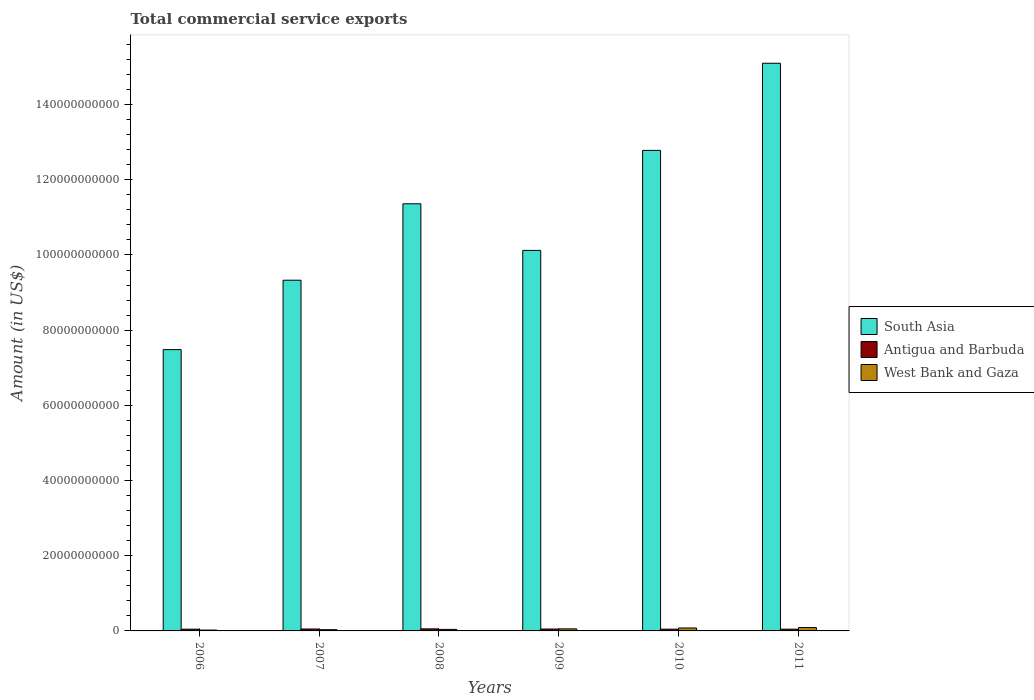How many groups of bars are there?
Your answer should be compact. 6. Are the number of bars per tick equal to the number of legend labels?
Offer a very short reply. Yes. Are the number of bars on each tick of the X-axis equal?
Your answer should be very brief. Yes. How many bars are there on the 6th tick from the left?
Your answer should be compact. 3. What is the label of the 6th group of bars from the left?
Offer a terse response. 2011. What is the total commercial service exports in West Bank and Gaza in 2009?
Make the answer very short. 5.57e+08. Across all years, what is the maximum total commercial service exports in Antigua and Barbuda?
Provide a succinct answer. 5.47e+08. Across all years, what is the minimum total commercial service exports in South Asia?
Give a very brief answer. 7.48e+1. In which year was the total commercial service exports in Antigua and Barbuda minimum?
Keep it short and to the point. 2006. What is the total total commercial service exports in West Bank and Gaza in the graph?
Offer a very short reply. 3.21e+09. What is the difference between the total commercial service exports in Antigua and Barbuda in 2006 and that in 2010?
Keep it short and to the point. -3.92e+06. What is the difference between the total commercial service exports in South Asia in 2008 and the total commercial service exports in Antigua and Barbuda in 2007?
Provide a short and direct response. 1.13e+11. What is the average total commercial service exports in West Bank and Gaza per year?
Keep it short and to the point. 5.34e+08. In the year 2010, what is the difference between the total commercial service exports in West Bank and Gaza and total commercial service exports in Antigua and Barbuda?
Your answer should be compact. 3.17e+08. In how many years, is the total commercial service exports in Antigua and Barbuda greater than 152000000000 US$?
Keep it short and to the point. 0. What is the ratio of the total commercial service exports in South Asia in 2006 to that in 2008?
Offer a very short reply. 0.66. What is the difference between the highest and the second highest total commercial service exports in Antigua and Barbuda?
Give a very brief answer. 3.73e+07. What is the difference between the highest and the lowest total commercial service exports in South Asia?
Ensure brevity in your answer.  7.62e+1. In how many years, is the total commercial service exports in West Bank and Gaza greater than the average total commercial service exports in West Bank and Gaza taken over all years?
Give a very brief answer. 3. What does the 2nd bar from the left in 2011 represents?
Provide a short and direct response. Antigua and Barbuda. Is it the case that in every year, the sum of the total commercial service exports in South Asia and total commercial service exports in West Bank and Gaza is greater than the total commercial service exports in Antigua and Barbuda?
Provide a succinct answer. Yes. How many bars are there?
Offer a very short reply. 18. How many years are there in the graph?
Offer a very short reply. 6. Does the graph contain grids?
Your response must be concise. No. What is the title of the graph?
Make the answer very short. Total commercial service exports. Does "France" appear as one of the legend labels in the graph?
Ensure brevity in your answer.  No. What is the Amount (in US$) in South Asia in 2006?
Offer a very short reply. 7.48e+1. What is the Amount (in US$) of Antigua and Barbuda in 2006?
Offer a very short reply. 4.62e+08. What is the Amount (in US$) of West Bank and Gaza in 2006?
Your response must be concise. 2.32e+08. What is the Amount (in US$) of South Asia in 2007?
Give a very brief answer. 9.33e+1. What is the Amount (in US$) in Antigua and Barbuda in 2007?
Your answer should be very brief. 5.10e+08. What is the Amount (in US$) in West Bank and Gaza in 2007?
Keep it short and to the point. 3.35e+08. What is the Amount (in US$) in South Asia in 2008?
Your answer should be very brief. 1.14e+11. What is the Amount (in US$) in Antigua and Barbuda in 2008?
Offer a very short reply. 5.47e+08. What is the Amount (in US$) of West Bank and Gaza in 2008?
Your response must be concise. 4.08e+08. What is the Amount (in US$) of South Asia in 2009?
Make the answer very short. 1.01e+11. What is the Amount (in US$) of Antigua and Barbuda in 2009?
Provide a succinct answer. 4.99e+08. What is the Amount (in US$) of West Bank and Gaza in 2009?
Offer a very short reply. 5.57e+08. What is the Amount (in US$) of South Asia in 2010?
Your answer should be compact. 1.28e+11. What is the Amount (in US$) of Antigua and Barbuda in 2010?
Make the answer very short. 4.66e+08. What is the Amount (in US$) of West Bank and Gaza in 2010?
Give a very brief answer. 7.83e+08. What is the Amount (in US$) in South Asia in 2011?
Your answer should be very brief. 1.51e+11. What is the Amount (in US$) of Antigua and Barbuda in 2011?
Offer a very short reply. 4.69e+08. What is the Amount (in US$) of West Bank and Gaza in 2011?
Your response must be concise. 8.92e+08. Across all years, what is the maximum Amount (in US$) in South Asia?
Your response must be concise. 1.51e+11. Across all years, what is the maximum Amount (in US$) of Antigua and Barbuda?
Your answer should be compact. 5.47e+08. Across all years, what is the maximum Amount (in US$) of West Bank and Gaza?
Provide a succinct answer. 8.92e+08. Across all years, what is the minimum Amount (in US$) of South Asia?
Your response must be concise. 7.48e+1. Across all years, what is the minimum Amount (in US$) of Antigua and Barbuda?
Ensure brevity in your answer.  4.62e+08. Across all years, what is the minimum Amount (in US$) in West Bank and Gaza?
Give a very brief answer. 2.32e+08. What is the total Amount (in US$) of South Asia in the graph?
Your answer should be compact. 6.62e+11. What is the total Amount (in US$) of Antigua and Barbuda in the graph?
Ensure brevity in your answer.  2.95e+09. What is the total Amount (in US$) of West Bank and Gaza in the graph?
Offer a very short reply. 3.21e+09. What is the difference between the Amount (in US$) in South Asia in 2006 and that in 2007?
Keep it short and to the point. -1.85e+1. What is the difference between the Amount (in US$) of Antigua and Barbuda in 2006 and that in 2007?
Offer a very short reply. -4.78e+07. What is the difference between the Amount (in US$) of West Bank and Gaza in 2006 and that in 2007?
Your answer should be very brief. -1.03e+08. What is the difference between the Amount (in US$) of South Asia in 2006 and that in 2008?
Offer a terse response. -3.88e+1. What is the difference between the Amount (in US$) of Antigua and Barbuda in 2006 and that in 2008?
Offer a terse response. -8.51e+07. What is the difference between the Amount (in US$) of West Bank and Gaza in 2006 and that in 2008?
Your answer should be compact. -1.76e+08. What is the difference between the Amount (in US$) of South Asia in 2006 and that in 2009?
Provide a succinct answer. -2.64e+1. What is the difference between the Amount (in US$) of Antigua and Barbuda in 2006 and that in 2009?
Provide a short and direct response. -3.71e+07. What is the difference between the Amount (in US$) in West Bank and Gaza in 2006 and that in 2009?
Offer a very short reply. -3.24e+08. What is the difference between the Amount (in US$) of South Asia in 2006 and that in 2010?
Make the answer very short. -5.30e+1. What is the difference between the Amount (in US$) in Antigua and Barbuda in 2006 and that in 2010?
Ensure brevity in your answer.  -3.92e+06. What is the difference between the Amount (in US$) of West Bank and Gaza in 2006 and that in 2010?
Give a very brief answer. -5.51e+08. What is the difference between the Amount (in US$) in South Asia in 2006 and that in 2011?
Keep it short and to the point. -7.62e+1. What is the difference between the Amount (in US$) in Antigua and Barbuda in 2006 and that in 2011?
Make the answer very short. -7.22e+06. What is the difference between the Amount (in US$) of West Bank and Gaza in 2006 and that in 2011?
Provide a succinct answer. -6.60e+08. What is the difference between the Amount (in US$) of South Asia in 2007 and that in 2008?
Your answer should be compact. -2.03e+1. What is the difference between the Amount (in US$) in Antigua and Barbuda in 2007 and that in 2008?
Give a very brief answer. -3.73e+07. What is the difference between the Amount (in US$) in West Bank and Gaza in 2007 and that in 2008?
Offer a terse response. -7.27e+07. What is the difference between the Amount (in US$) in South Asia in 2007 and that in 2009?
Offer a terse response. -7.93e+09. What is the difference between the Amount (in US$) in Antigua and Barbuda in 2007 and that in 2009?
Your response must be concise. 1.07e+07. What is the difference between the Amount (in US$) in West Bank and Gaza in 2007 and that in 2009?
Ensure brevity in your answer.  -2.22e+08. What is the difference between the Amount (in US$) in South Asia in 2007 and that in 2010?
Ensure brevity in your answer.  -3.45e+1. What is the difference between the Amount (in US$) of Antigua and Barbuda in 2007 and that in 2010?
Provide a succinct answer. 4.39e+07. What is the difference between the Amount (in US$) of West Bank and Gaza in 2007 and that in 2010?
Offer a very short reply. -4.49e+08. What is the difference between the Amount (in US$) of South Asia in 2007 and that in 2011?
Offer a terse response. -5.77e+1. What is the difference between the Amount (in US$) in Antigua and Barbuda in 2007 and that in 2011?
Provide a short and direct response. 4.06e+07. What is the difference between the Amount (in US$) of West Bank and Gaza in 2007 and that in 2011?
Your response must be concise. -5.57e+08. What is the difference between the Amount (in US$) in South Asia in 2008 and that in 2009?
Keep it short and to the point. 1.24e+1. What is the difference between the Amount (in US$) in Antigua and Barbuda in 2008 and that in 2009?
Provide a short and direct response. 4.81e+07. What is the difference between the Amount (in US$) in West Bank and Gaza in 2008 and that in 2009?
Your answer should be compact. -1.49e+08. What is the difference between the Amount (in US$) in South Asia in 2008 and that in 2010?
Make the answer very short. -1.42e+1. What is the difference between the Amount (in US$) in Antigua and Barbuda in 2008 and that in 2010?
Give a very brief answer. 8.12e+07. What is the difference between the Amount (in US$) of West Bank and Gaza in 2008 and that in 2010?
Your answer should be compact. -3.76e+08. What is the difference between the Amount (in US$) in South Asia in 2008 and that in 2011?
Give a very brief answer. -3.74e+1. What is the difference between the Amount (in US$) of Antigua and Barbuda in 2008 and that in 2011?
Give a very brief answer. 7.79e+07. What is the difference between the Amount (in US$) in West Bank and Gaza in 2008 and that in 2011?
Offer a very short reply. -4.84e+08. What is the difference between the Amount (in US$) of South Asia in 2009 and that in 2010?
Provide a short and direct response. -2.66e+1. What is the difference between the Amount (in US$) in Antigua and Barbuda in 2009 and that in 2010?
Ensure brevity in your answer.  3.32e+07. What is the difference between the Amount (in US$) of West Bank and Gaza in 2009 and that in 2010?
Provide a succinct answer. -2.27e+08. What is the difference between the Amount (in US$) in South Asia in 2009 and that in 2011?
Offer a very short reply. -4.98e+1. What is the difference between the Amount (in US$) in Antigua and Barbuda in 2009 and that in 2011?
Provide a succinct answer. 2.99e+07. What is the difference between the Amount (in US$) in West Bank and Gaza in 2009 and that in 2011?
Keep it short and to the point. -3.35e+08. What is the difference between the Amount (in US$) in South Asia in 2010 and that in 2011?
Provide a succinct answer. -2.32e+1. What is the difference between the Amount (in US$) of Antigua and Barbuda in 2010 and that in 2011?
Your response must be concise. -3.30e+06. What is the difference between the Amount (in US$) of West Bank and Gaza in 2010 and that in 2011?
Make the answer very short. -1.08e+08. What is the difference between the Amount (in US$) of South Asia in 2006 and the Amount (in US$) of Antigua and Barbuda in 2007?
Give a very brief answer. 7.43e+1. What is the difference between the Amount (in US$) of South Asia in 2006 and the Amount (in US$) of West Bank and Gaza in 2007?
Give a very brief answer. 7.45e+1. What is the difference between the Amount (in US$) in Antigua and Barbuda in 2006 and the Amount (in US$) in West Bank and Gaza in 2007?
Make the answer very short. 1.27e+08. What is the difference between the Amount (in US$) of South Asia in 2006 and the Amount (in US$) of Antigua and Barbuda in 2008?
Your answer should be compact. 7.43e+1. What is the difference between the Amount (in US$) of South Asia in 2006 and the Amount (in US$) of West Bank and Gaza in 2008?
Ensure brevity in your answer.  7.44e+1. What is the difference between the Amount (in US$) in Antigua and Barbuda in 2006 and the Amount (in US$) in West Bank and Gaza in 2008?
Make the answer very short. 5.46e+07. What is the difference between the Amount (in US$) of South Asia in 2006 and the Amount (in US$) of Antigua and Barbuda in 2009?
Offer a very short reply. 7.43e+1. What is the difference between the Amount (in US$) of South Asia in 2006 and the Amount (in US$) of West Bank and Gaza in 2009?
Your response must be concise. 7.43e+1. What is the difference between the Amount (in US$) in Antigua and Barbuda in 2006 and the Amount (in US$) in West Bank and Gaza in 2009?
Your answer should be compact. -9.44e+07. What is the difference between the Amount (in US$) in South Asia in 2006 and the Amount (in US$) in Antigua and Barbuda in 2010?
Make the answer very short. 7.44e+1. What is the difference between the Amount (in US$) of South Asia in 2006 and the Amount (in US$) of West Bank and Gaza in 2010?
Give a very brief answer. 7.40e+1. What is the difference between the Amount (in US$) in Antigua and Barbuda in 2006 and the Amount (in US$) in West Bank and Gaza in 2010?
Ensure brevity in your answer.  -3.21e+08. What is the difference between the Amount (in US$) in South Asia in 2006 and the Amount (in US$) in Antigua and Barbuda in 2011?
Your answer should be very brief. 7.44e+1. What is the difference between the Amount (in US$) in South Asia in 2006 and the Amount (in US$) in West Bank and Gaza in 2011?
Your answer should be very brief. 7.39e+1. What is the difference between the Amount (in US$) of Antigua and Barbuda in 2006 and the Amount (in US$) of West Bank and Gaza in 2011?
Provide a short and direct response. -4.29e+08. What is the difference between the Amount (in US$) in South Asia in 2007 and the Amount (in US$) in Antigua and Barbuda in 2008?
Ensure brevity in your answer.  9.27e+1. What is the difference between the Amount (in US$) of South Asia in 2007 and the Amount (in US$) of West Bank and Gaza in 2008?
Offer a very short reply. 9.29e+1. What is the difference between the Amount (in US$) of Antigua and Barbuda in 2007 and the Amount (in US$) of West Bank and Gaza in 2008?
Provide a succinct answer. 1.02e+08. What is the difference between the Amount (in US$) in South Asia in 2007 and the Amount (in US$) in Antigua and Barbuda in 2009?
Offer a terse response. 9.28e+1. What is the difference between the Amount (in US$) in South Asia in 2007 and the Amount (in US$) in West Bank and Gaza in 2009?
Offer a terse response. 9.27e+1. What is the difference between the Amount (in US$) in Antigua and Barbuda in 2007 and the Amount (in US$) in West Bank and Gaza in 2009?
Offer a very short reply. -4.65e+07. What is the difference between the Amount (in US$) of South Asia in 2007 and the Amount (in US$) of Antigua and Barbuda in 2010?
Offer a very short reply. 9.28e+1. What is the difference between the Amount (in US$) of South Asia in 2007 and the Amount (in US$) of West Bank and Gaza in 2010?
Offer a very short reply. 9.25e+1. What is the difference between the Amount (in US$) in Antigua and Barbuda in 2007 and the Amount (in US$) in West Bank and Gaza in 2010?
Ensure brevity in your answer.  -2.73e+08. What is the difference between the Amount (in US$) of South Asia in 2007 and the Amount (in US$) of Antigua and Barbuda in 2011?
Your response must be concise. 9.28e+1. What is the difference between the Amount (in US$) of South Asia in 2007 and the Amount (in US$) of West Bank and Gaza in 2011?
Make the answer very short. 9.24e+1. What is the difference between the Amount (in US$) of Antigua and Barbuda in 2007 and the Amount (in US$) of West Bank and Gaza in 2011?
Provide a succinct answer. -3.82e+08. What is the difference between the Amount (in US$) in South Asia in 2008 and the Amount (in US$) in Antigua and Barbuda in 2009?
Keep it short and to the point. 1.13e+11. What is the difference between the Amount (in US$) in South Asia in 2008 and the Amount (in US$) in West Bank and Gaza in 2009?
Your response must be concise. 1.13e+11. What is the difference between the Amount (in US$) of Antigua and Barbuda in 2008 and the Amount (in US$) of West Bank and Gaza in 2009?
Give a very brief answer. -9.21e+06. What is the difference between the Amount (in US$) of South Asia in 2008 and the Amount (in US$) of Antigua and Barbuda in 2010?
Your response must be concise. 1.13e+11. What is the difference between the Amount (in US$) in South Asia in 2008 and the Amount (in US$) in West Bank and Gaza in 2010?
Keep it short and to the point. 1.13e+11. What is the difference between the Amount (in US$) in Antigua and Barbuda in 2008 and the Amount (in US$) in West Bank and Gaza in 2010?
Your answer should be compact. -2.36e+08. What is the difference between the Amount (in US$) in South Asia in 2008 and the Amount (in US$) in Antigua and Barbuda in 2011?
Offer a very short reply. 1.13e+11. What is the difference between the Amount (in US$) in South Asia in 2008 and the Amount (in US$) in West Bank and Gaza in 2011?
Provide a succinct answer. 1.13e+11. What is the difference between the Amount (in US$) of Antigua and Barbuda in 2008 and the Amount (in US$) of West Bank and Gaza in 2011?
Your response must be concise. -3.44e+08. What is the difference between the Amount (in US$) of South Asia in 2009 and the Amount (in US$) of Antigua and Barbuda in 2010?
Provide a short and direct response. 1.01e+11. What is the difference between the Amount (in US$) of South Asia in 2009 and the Amount (in US$) of West Bank and Gaza in 2010?
Your response must be concise. 1.00e+11. What is the difference between the Amount (in US$) in Antigua and Barbuda in 2009 and the Amount (in US$) in West Bank and Gaza in 2010?
Give a very brief answer. -2.84e+08. What is the difference between the Amount (in US$) of South Asia in 2009 and the Amount (in US$) of Antigua and Barbuda in 2011?
Ensure brevity in your answer.  1.01e+11. What is the difference between the Amount (in US$) in South Asia in 2009 and the Amount (in US$) in West Bank and Gaza in 2011?
Give a very brief answer. 1.00e+11. What is the difference between the Amount (in US$) in Antigua and Barbuda in 2009 and the Amount (in US$) in West Bank and Gaza in 2011?
Keep it short and to the point. -3.92e+08. What is the difference between the Amount (in US$) in South Asia in 2010 and the Amount (in US$) in Antigua and Barbuda in 2011?
Give a very brief answer. 1.27e+11. What is the difference between the Amount (in US$) in South Asia in 2010 and the Amount (in US$) in West Bank and Gaza in 2011?
Your answer should be very brief. 1.27e+11. What is the difference between the Amount (in US$) in Antigua and Barbuda in 2010 and the Amount (in US$) in West Bank and Gaza in 2011?
Your answer should be compact. -4.26e+08. What is the average Amount (in US$) of South Asia per year?
Your answer should be compact. 1.10e+11. What is the average Amount (in US$) in Antigua and Barbuda per year?
Make the answer very short. 4.92e+08. What is the average Amount (in US$) in West Bank and Gaza per year?
Offer a very short reply. 5.34e+08. In the year 2006, what is the difference between the Amount (in US$) in South Asia and Amount (in US$) in Antigua and Barbuda?
Give a very brief answer. 7.44e+1. In the year 2006, what is the difference between the Amount (in US$) of South Asia and Amount (in US$) of West Bank and Gaza?
Keep it short and to the point. 7.46e+1. In the year 2006, what is the difference between the Amount (in US$) of Antigua and Barbuda and Amount (in US$) of West Bank and Gaza?
Ensure brevity in your answer.  2.30e+08. In the year 2007, what is the difference between the Amount (in US$) of South Asia and Amount (in US$) of Antigua and Barbuda?
Offer a terse response. 9.28e+1. In the year 2007, what is the difference between the Amount (in US$) in South Asia and Amount (in US$) in West Bank and Gaza?
Keep it short and to the point. 9.30e+1. In the year 2007, what is the difference between the Amount (in US$) in Antigua and Barbuda and Amount (in US$) in West Bank and Gaza?
Provide a succinct answer. 1.75e+08. In the year 2008, what is the difference between the Amount (in US$) in South Asia and Amount (in US$) in Antigua and Barbuda?
Your answer should be compact. 1.13e+11. In the year 2008, what is the difference between the Amount (in US$) in South Asia and Amount (in US$) in West Bank and Gaza?
Provide a short and direct response. 1.13e+11. In the year 2008, what is the difference between the Amount (in US$) in Antigua and Barbuda and Amount (in US$) in West Bank and Gaza?
Your answer should be compact. 1.40e+08. In the year 2009, what is the difference between the Amount (in US$) in South Asia and Amount (in US$) in Antigua and Barbuda?
Ensure brevity in your answer.  1.01e+11. In the year 2009, what is the difference between the Amount (in US$) in South Asia and Amount (in US$) in West Bank and Gaza?
Offer a very short reply. 1.01e+11. In the year 2009, what is the difference between the Amount (in US$) in Antigua and Barbuda and Amount (in US$) in West Bank and Gaza?
Offer a very short reply. -5.73e+07. In the year 2010, what is the difference between the Amount (in US$) of South Asia and Amount (in US$) of Antigua and Barbuda?
Keep it short and to the point. 1.27e+11. In the year 2010, what is the difference between the Amount (in US$) of South Asia and Amount (in US$) of West Bank and Gaza?
Offer a very short reply. 1.27e+11. In the year 2010, what is the difference between the Amount (in US$) of Antigua and Barbuda and Amount (in US$) of West Bank and Gaza?
Your answer should be very brief. -3.17e+08. In the year 2011, what is the difference between the Amount (in US$) of South Asia and Amount (in US$) of Antigua and Barbuda?
Keep it short and to the point. 1.51e+11. In the year 2011, what is the difference between the Amount (in US$) in South Asia and Amount (in US$) in West Bank and Gaza?
Make the answer very short. 1.50e+11. In the year 2011, what is the difference between the Amount (in US$) in Antigua and Barbuda and Amount (in US$) in West Bank and Gaza?
Offer a terse response. -4.22e+08. What is the ratio of the Amount (in US$) in South Asia in 2006 to that in 2007?
Offer a very short reply. 0.8. What is the ratio of the Amount (in US$) of Antigua and Barbuda in 2006 to that in 2007?
Offer a terse response. 0.91. What is the ratio of the Amount (in US$) in West Bank and Gaza in 2006 to that in 2007?
Your answer should be very brief. 0.69. What is the ratio of the Amount (in US$) of South Asia in 2006 to that in 2008?
Your answer should be very brief. 0.66. What is the ratio of the Amount (in US$) of Antigua and Barbuda in 2006 to that in 2008?
Make the answer very short. 0.84. What is the ratio of the Amount (in US$) in West Bank and Gaza in 2006 to that in 2008?
Give a very brief answer. 0.57. What is the ratio of the Amount (in US$) in South Asia in 2006 to that in 2009?
Offer a terse response. 0.74. What is the ratio of the Amount (in US$) of Antigua and Barbuda in 2006 to that in 2009?
Provide a short and direct response. 0.93. What is the ratio of the Amount (in US$) of West Bank and Gaza in 2006 to that in 2009?
Make the answer very short. 0.42. What is the ratio of the Amount (in US$) of South Asia in 2006 to that in 2010?
Provide a short and direct response. 0.59. What is the ratio of the Amount (in US$) in Antigua and Barbuda in 2006 to that in 2010?
Ensure brevity in your answer.  0.99. What is the ratio of the Amount (in US$) of West Bank and Gaza in 2006 to that in 2010?
Keep it short and to the point. 0.3. What is the ratio of the Amount (in US$) in South Asia in 2006 to that in 2011?
Make the answer very short. 0.5. What is the ratio of the Amount (in US$) of Antigua and Barbuda in 2006 to that in 2011?
Ensure brevity in your answer.  0.98. What is the ratio of the Amount (in US$) of West Bank and Gaza in 2006 to that in 2011?
Offer a very short reply. 0.26. What is the ratio of the Amount (in US$) in South Asia in 2007 to that in 2008?
Offer a very short reply. 0.82. What is the ratio of the Amount (in US$) of Antigua and Barbuda in 2007 to that in 2008?
Offer a terse response. 0.93. What is the ratio of the Amount (in US$) in West Bank and Gaza in 2007 to that in 2008?
Provide a short and direct response. 0.82. What is the ratio of the Amount (in US$) in South Asia in 2007 to that in 2009?
Give a very brief answer. 0.92. What is the ratio of the Amount (in US$) of Antigua and Barbuda in 2007 to that in 2009?
Keep it short and to the point. 1.02. What is the ratio of the Amount (in US$) of West Bank and Gaza in 2007 to that in 2009?
Your answer should be very brief. 0.6. What is the ratio of the Amount (in US$) in South Asia in 2007 to that in 2010?
Give a very brief answer. 0.73. What is the ratio of the Amount (in US$) of Antigua and Barbuda in 2007 to that in 2010?
Your response must be concise. 1.09. What is the ratio of the Amount (in US$) in West Bank and Gaza in 2007 to that in 2010?
Your answer should be compact. 0.43. What is the ratio of the Amount (in US$) in South Asia in 2007 to that in 2011?
Provide a short and direct response. 0.62. What is the ratio of the Amount (in US$) of Antigua and Barbuda in 2007 to that in 2011?
Your answer should be compact. 1.09. What is the ratio of the Amount (in US$) of West Bank and Gaza in 2007 to that in 2011?
Make the answer very short. 0.38. What is the ratio of the Amount (in US$) in South Asia in 2008 to that in 2009?
Your answer should be very brief. 1.12. What is the ratio of the Amount (in US$) in Antigua and Barbuda in 2008 to that in 2009?
Provide a short and direct response. 1.1. What is the ratio of the Amount (in US$) in West Bank and Gaza in 2008 to that in 2009?
Keep it short and to the point. 0.73. What is the ratio of the Amount (in US$) of Antigua and Barbuda in 2008 to that in 2010?
Provide a short and direct response. 1.17. What is the ratio of the Amount (in US$) in West Bank and Gaza in 2008 to that in 2010?
Give a very brief answer. 0.52. What is the ratio of the Amount (in US$) of South Asia in 2008 to that in 2011?
Offer a very short reply. 0.75. What is the ratio of the Amount (in US$) in Antigua and Barbuda in 2008 to that in 2011?
Offer a very short reply. 1.17. What is the ratio of the Amount (in US$) in West Bank and Gaza in 2008 to that in 2011?
Give a very brief answer. 0.46. What is the ratio of the Amount (in US$) of South Asia in 2009 to that in 2010?
Your answer should be very brief. 0.79. What is the ratio of the Amount (in US$) in Antigua and Barbuda in 2009 to that in 2010?
Provide a succinct answer. 1.07. What is the ratio of the Amount (in US$) in West Bank and Gaza in 2009 to that in 2010?
Your response must be concise. 0.71. What is the ratio of the Amount (in US$) of South Asia in 2009 to that in 2011?
Offer a terse response. 0.67. What is the ratio of the Amount (in US$) of Antigua and Barbuda in 2009 to that in 2011?
Offer a terse response. 1.06. What is the ratio of the Amount (in US$) in West Bank and Gaza in 2009 to that in 2011?
Offer a very short reply. 0.62. What is the ratio of the Amount (in US$) of South Asia in 2010 to that in 2011?
Make the answer very short. 0.85. What is the ratio of the Amount (in US$) in West Bank and Gaza in 2010 to that in 2011?
Provide a succinct answer. 0.88. What is the difference between the highest and the second highest Amount (in US$) of South Asia?
Your response must be concise. 2.32e+1. What is the difference between the highest and the second highest Amount (in US$) in Antigua and Barbuda?
Offer a very short reply. 3.73e+07. What is the difference between the highest and the second highest Amount (in US$) in West Bank and Gaza?
Keep it short and to the point. 1.08e+08. What is the difference between the highest and the lowest Amount (in US$) of South Asia?
Offer a very short reply. 7.62e+1. What is the difference between the highest and the lowest Amount (in US$) in Antigua and Barbuda?
Your answer should be compact. 8.51e+07. What is the difference between the highest and the lowest Amount (in US$) in West Bank and Gaza?
Offer a very short reply. 6.60e+08. 